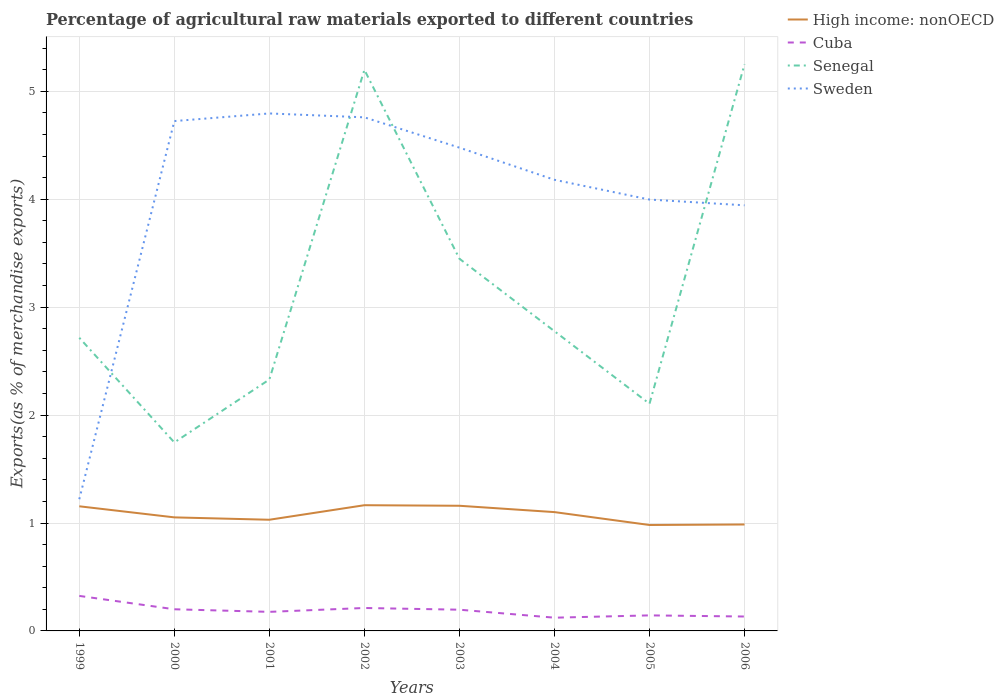How many different coloured lines are there?
Provide a succinct answer. 4. Does the line corresponding to Cuba intersect with the line corresponding to Senegal?
Your answer should be very brief. No. Is the number of lines equal to the number of legend labels?
Provide a succinct answer. Yes. Across all years, what is the maximum percentage of exports to different countries in Senegal?
Ensure brevity in your answer.  1.75. What is the total percentage of exports to different countries in Cuba in the graph?
Offer a terse response. 0.02. What is the difference between the highest and the second highest percentage of exports to different countries in Sweden?
Offer a terse response. 3.57. What is the difference between the highest and the lowest percentage of exports to different countries in Sweden?
Give a very brief answer. 5. Is the percentage of exports to different countries in Cuba strictly greater than the percentage of exports to different countries in High income: nonOECD over the years?
Ensure brevity in your answer.  Yes. How many lines are there?
Ensure brevity in your answer.  4. Does the graph contain any zero values?
Give a very brief answer. No. Where does the legend appear in the graph?
Ensure brevity in your answer.  Top right. How many legend labels are there?
Your answer should be compact. 4. How are the legend labels stacked?
Offer a terse response. Vertical. What is the title of the graph?
Your answer should be compact. Percentage of agricultural raw materials exported to different countries. Does "Nicaragua" appear as one of the legend labels in the graph?
Ensure brevity in your answer.  No. What is the label or title of the Y-axis?
Your answer should be very brief. Exports(as % of merchandise exports). What is the Exports(as % of merchandise exports) in High income: nonOECD in 1999?
Your answer should be compact. 1.15. What is the Exports(as % of merchandise exports) of Cuba in 1999?
Offer a very short reply. 0.32. What is the Exports(as % of merchandise exports) in Senegal in 1999?
Ensure brevity in your answer.  2.72. What is the Exports(as % of merchandise exports) in Sweden in 1999?
Provide a succinct answer. 1.22. What is the Exports(as % of merchandise exports) of High income: nonOECD in 2000?
Your answer should be compact. 1.05. What is the Exports(as % of merchandise exports) in Cuba in 2000?
Your answer should be very brief. 0.2. What is the Exports(as % of merchandise exports) of Senegal in 2000?
Provide a succinct answer. 1.75. What is the Exports(as % of merchandise exports) in Sweden in 2000?
Provide a succinct answer. 4.72. What is the Exports(as % of merchandise exports) in High income: nonOECD in 2001?
Keep it short and to the point. 1.03. What is the Exports(as % of merchandise exports) in Cuba in 2001?
Give a very brief answer. 0.18. What is the Exports(as % of merchandise exports) in Senegal in 2001?
Offer a terse response. 2.33. What is the Exports(as % of merchandise exports) in Sweden in 2001?
Provide a short and direct response. 4.8. What is the Exports(as % of merchandise exports) in High income: nonOECD in 2002?
Make the answer very short. 1.16. What is the Exports(as % of merchandise exports) of Cuba in 2002?
Make the answer very short. 0.21. What is the Exports(as % of merchandise exports) in Senegal in 2002?
Make the answer very short. 5.2. What is the Exports(as % of merchandise exports) in Sweden in 2002?
Make the answer very short. 4.76. What is the Exports(as % of merchandise exports) of High income: nonOECD in 2003?
Give a very brief answer. 1.16. What is the Exports(as % of merchandise exports) of Cuba in 2003?
Provide a short and direct response. 0.2. What is the Exports(as % of merchandise exports) of Senegal in 2003?
Provide a short and direct response. 3.45. What is the Exports(as % of merchandise exports) of Sweden in 2003?
Give a very brief answer. 4.48. What is the Exports(as % of merchandise exports) of High income: nonOECD in 2004?
Your answer should be very brief. 1.1. What is the Exports(as % of merchandise exports) of Cuba in 2004?
Your response must be concise. 0.12. What is the Exports(as % of merchandise exports) in Senegal in 2004?
Your answer should be very brief. 2.78. What is the Exports(as % of merchandise exports) of Sweden in 2004?
Offer a terse response. 4.18. What is the Exports(as % of merchandise exports) in High income: nonOECD in 2005?
Ensure brevity in your answer.  0.98. What is the Exports(as % of merchandise exports) in Cuba in 2005?
Your answer should be very brief. 0.14. What is the Exports(as % of merchandise exports) of Senegal in 2005?
Keep it short and to the point. 2.11. What is the Exports(as % of merchandise exports) of Sweden in 2005?
Ensure brevity in your answer.  4. What is the Exports(as % of merchandise exports) in High income: nonOECD in 2006?
Give a very brief answer. 0.99. What is the Exports(as % of merchandise exports) of Cuba in 2006?
Offer a terse response. 0.13. What is the Exports(as % of merchandise exports) in Senegal in 2006?
Offer a terse response. 5.25. What is the Exports(as % of merchandise exports) of Sweden in 2006?
Provide a succinct answer. 3.94. Across all years, what is the maximum Exports(as % of merchandise exports) of High income: nonOECD?
Keep it short and to the point. 1.16. Across all years, what is the maximum Exports(as % of merchandise exports) of Cuba?
Your response must be concise. 0.32. Across all years, what is the maximum Exports(as % of merchandise exports) in Senegal?
Ensure brevity in your answer.  5.25. Across all years, what is the maximum Exports(as % of merchandise exports) of Sweden?
Your answer should be compact. 4.8. Across all years, what is the minimum Exports(as % of merchandise exports) in High income: nonOECD?
Keep it short and to the point. 0.98. Across all years, what is the minimum Exports(as % of merchandise exports) in Cuba?
Provide a succinct answer. 0.12. Across all years, what is the minimum Exports(as % of merchandise exports) of Senegal?
Ensure brevity in your answer.  1.75. Across all years, what is the minimum Exports(as % of merchandise exports) of Sweden?
Offer a very short reply. 1.22. What is the total Exports(as % of merchandise exports) in High income: nonOECD in the graph?
Keep it short and to the point. 8.63. What is the total Exports(as % of merchandise exports) in Cuba in the graph?
Your response must be concise. 1.51. What is the total Exports(as % of merchandise exports) of Senegal in the graph?
Your response must be concise. 25.57. What is the total Exports(as % of merchandise exports) of Sweden in the graph?
Your answer should be very brief. 32.1. What is the difference between the Exports(as % of merchandise exports) of High income: nonOECD in 1999 and that in 2000?
Ensure brevity in your answer.  0.1. What is the difference between the Exports(as % of merchandise exports) in Cuba in 1999 and that in 2000?
Ensure brevity in your answer.  0.12. What is the difference between the Exports(as % of merchandise exports) of Senegal in 1999 and that in 2000?
Offer a terse response. 0.97. What is the difference between the Exports(as % of merchandise exports) of Sweden in 1999 and that in 2000?
Your answer should be compact. -3.5. What is the difference between the Exports(as % of merchandise exports) in High income: nonOECD in 1999 and that in 2001?
Offer a terse response. 0.12. What is the difference between the Exports(as % of merchandise exports) of Cuba in 1999 and that in 2001?
Keep it short and to the point. 0.15. What is the difference between the Exports(as % of merchandise exports) of Senegal in 1999 and that in 2001?
Your answer should be compact. 0.39. What is the difference between the Exports(as % of merchandise exports) of Sweden in 1999 and that in 2001?
Ensure brevity in your answer.  -3.57. What is the difference between the Exports(as % of merchandise exports) of High income: nonOECD in 1999 and that in 2002?
Offer a very short reply. -0.01. What is the difference between the Exports(as % of merchandise exports) in Cuba in 1999 and that in 2002?
Your answer should be very brief. 0.11. What is the difference between the Exports(as % of merchandise exports) of Senegal in 1999 and that in 2002?
Offer a very short reply. -2.48. What is the difference between the Exports(as % of merchandise exports) of Sweden in 1999 and that in 2002?
Keep it short and to the point. -3.54. What is the difference between the Exports(as % of merchandise exports) of High income: nonOECD in 1999 and that in 2003?
Make the answer very short. -0. What is the difference between the Exports(as % of merchandise exports) in Cuba in 1999 and that in 2003?
Offer a terse response. 0.13. What is the difference between the Exports(as % of merchandise exports) in Senegal in 1999 and that in 2003?
Give a very brief answer. -0.73. What is the difference between the Exports(as % of merchandise exports) in Sweden in 1999 and that in 2003?
Ensure brevity in your answer.  -3.26. What is the difference between the Exports(as % of merchandise exports) in High income: nonOECD in 1999 and that in 2004?
Your answer should be very brief. 0.05. What is the difference between the Exports(as % of merchandise exports) in Cuba in 1999 and that in 2004?
Your answer should be very brief. 0.2. What is the difference between the Exports(as % of merchandise exports) in Senegal in 1999 and that in 2004?
Make the answer very short. -0.06. What is the difference between the Exports(as % of merchandise exports) of Sweden in 1999 and that in 2004?
Offer a terse response. -2.96. What is the difference between the Exports(as % of merchandise exports) in High income: nonOECD in 1999 and that in 2005?
Keep it short and to the point. 0.17. What is the difference between the Exports(as % of merchandise exports) of Cuba in 1999 and that in 2005?
Make the answer very short. 0.18. What is the difference between the Exports(as % of merchandise exports) in Senegal in 1999 and that in 2005?
Offer a very short reply. 0.61. What is the difference between the Exports(as % of merchandise exports) in Sweden in 1999 and that in 2005?
Offer a terse response. -2.78. What is the difference between the Exports(as % of merchandise exports) of High income: nonOECD in 1999 and that in 2006?
Keep it short and to the point. 0.17. What is the difference between the Exports(as % of merchandise exports) in Cuba in 1999 and that in 2006?
Give a very brief answer. 0.19. What is the difference between the Exports(as % of merchandise exports) in Senegal in 1999 and that in 2006?
Offer a very short reply. -2.53. What is the difference between the Exports(as % of merchandise exports) of Sweden in 1999 and that in 2006?
Ensure brevity in your answer.  -2.72. What is the difference between the Exports(as % of merchandise exports) in High income: nonOECD in 2000 and that in 2001?
Your answer should be very brief. 0.02. What is the difference between the Exports(as % of merchandise exports) of Cuba in 2000 and that in 2001?
Provide a succinct answer. 0.02. What is the difference between the Exports(as % of merchandise exports) in Senegal in 2000 and that in 2001?
Your response must be concise. -0.58. What is the difference between the Exports(as % of merchandise exports) in Sweden in 2000 and that in 2001?
Ensure brevity in your answer.  -0.07. What is the difference between the Exports(as % of merchandise exports) of High income: nonOECD in 2000 and that in 2002?
Give a very brief answer. -0.11. What is the difference between the Exports(as % of merchandise exports) in Cuba in 2000 and that in 2002?
Provide a short and direct response. -0.01. What is the difference between the Exports(as % of merchandise exports) of Senegal in 2000 and that in 2002?
Your response must be concise. -3.45. What is the difference between the Exports(as % of merchandise exports) in Sweden in 2000 and that in 2002?
Your answer should be very brief. -0.03. What is the difference between the Exports(as % of merchandise exports) in High income: nonOECD in 2000 and that in 2003?
Provide a short and direct response. -0.11. What is the difference between the Exports(as % of merchandise exports) in Cuba in 2000 and that in 2003?
Ensure brevity in your answer.  0. What is the difference between the Exports(as % of merchandise exports) of Senegal in 2000 and that in 2003?
Your response must be concise. -1.7. What is the difference between the Exports(as % of merchandise exports) in Sweden in 2000 and that in 2003?
Your response must be concise. 0.25. What is the difference between the Exports(as % of merchandise exports) of High income: nonOECD in 2000 and that in 2004?
Provide a short and direct response. -0.05. What is the difference between the Exports(as % of merchandise exports) of Cuba in 2000 and that in 2004?
Make the answer very short. 0.08. What is the difference between the Exports(as % of merchandise exports) in Senegal in 2000 and that in 2004?
Make the answer very short. -1.03. What is the difference between the Exports(as % of merchandise exports) in Sweden in 2000 and that in 2004?
Ensure brevity in your answer.  0.54. What is the difference between the Exports(as % of merchandise exports) in High income: nonOECD in 2000 and that in 2005?
Provide a succinct answer. 0.07. What is the difference between the Exports(as % of merchandise exports) in Cuba in 2000 and that in 2005?
Ensure brevity in your answer.  0.06. What is the difference between the Exports(as % of merchandise exports) in Senegal in 2000 and that in 2005?
Your answer should be compact. -0.36. What is the difference between the Exports(as % of merchandise exports) of Sweden in 2000 and that in 2005?
Offer a very short reply. 0.73. What is the difference between the Exports(as % of merchandise exports) of High income: nonOECD in 2000 and that in 2006?
Offer a terse response. 0.07. What is the difference between the Exports(as % of merchandise exports) of Cuba in 2000 and that in 2006?
Provide a succinct answer. 0.07. What is the difference between the Exports(as % of merchandise exports) in Senegal in 2000 and that in 2006?
Make the answer very short. -3.5. What is the difference between the Exports(as % of merchandise exports) in Sweden in 2000 and that in 2006?
Your answer should be compact. 0.78. What is the difference between the Exports(as % of merchandise exports) of High income: nonOECD in 2001 and that in 2002?
Offer a very short reply. -0.13. What is the difference between the Exports(as % of merchandise exports) of Cuba in 2001 and that in 2002?
Keep it short and to the point. -0.04. What is the difference between the Exports(as % of merchandise exports) in Senegal in 2001 and that in 2002?
Offer a very short reply. -2.87. What is the difference between the Exports(as % of merchandise exports) of Sweden in 2001 and that in 2002?
Give a very brief answer. 0.04. What is the difference between the Exports(as % of merchandise exports) in High income: nonOECD in 2001 and that in 2003?
Provide a succinct answer. -0.13. What is the difference between the Exports(as % of merchandise exports) of Cuba in 2001 and that in 2003?
Offer a very short reply. -0.02. What is the difference between the Exports(as % of merchandise exports) of Senegal in 2001 and that in 2003?
Your answer should be compact. -1.12. What is the difference between the Exports(as % of merchandise exports) in Sweden in 2001 and that in 2003?
Keep it short and to the point. 0.32. What is the difference between the Exports(as % of merchandise exports) in High income: nonOECD in 2001 and that in 2004?
Your answer should be compact. -0.07. What is the difference between the Exports(as % of merchandise exports) of Cuba in 2001 and that in 2004?
Offer a terse response. 0.05. What is the difference between the Exports(as % of merchandise exports) of Senegal in 2001 and that in 2004?
Provide a short and direct response. -0.45. What is the difference between the Exports(as % of merchandise exports) in Sweden in 2001 and that in 2004?
Offer a very short reply. 0.61. What is the difference between the Exports(as % of merchandise exports) in High income: nonOECD in 2001 and that in 2005?
Provide a succinct answer. 0.05. What is the difference between the Exports(as % of merchandise exports) in Cuba in 2001 and that in 2005?
Make the answer very short. 0.03. What is the difference between the Exports(as % of merchandise exports) in Senegal in 2001 and that in 2005?
Offer a very short reply. 0.22. What is the difference between the Exports(as % of merchandise exports) of Sweden in 2001 and that in 2005?
Keep it short and to the point. 0.8. What is the difference between the Exports(as % of merchandise exports) of High income: nonOECD in 2001 and that in 2006?
Your answer should be compact. 0.04. What is the difference between the Exports(as % of merchandise exports) in Cuba in 2001 and that in 2006?
Your answer should be compact. 0.04. What is the difference between the Exports(as % of merchandise exports) of Senegal in 2001 and that in 2006?
Offer a terse response. -2.92. What is the difference between the Exports(as % of merchandise exports) of Sweden in 2001 and that in 2006?
Provide a short and direct response. 0.85. What is the difference between the Exports(as % of merchandise exports) in High income: nonOECD in 2002 and that in 2003?
Your answer should be compact. 0.01. What is the difference between the Exports(as % of merchandise exports) of Cuba in 2002 and that in 2003?
Offer a terse response. 0.02. What is the difference between the Exports(as % of merchandise exports) in Senegal in 2002 and that in 2003?
Give a very brief answer. 1.75. What is the difference between the Exports(as % of merchandise exports) of Sweden in 2002 and that in 2003?
Provide a succinct answer. 0.28. What is the difference between the Exports(as % of merchandise exports) of High income: nonOECD in 2002 and that in 2004?
Provide a succinct answer. 0.06. What is the difference between the Exports(as % of merchandise exports) in Cuba in 2002 and that in 2004?
Keep it short and to the point. 0.09. What is the difference between the Exports(as % of merchandise exports) in Senegal in 2002 and that in 2004?
Ensure brevity in your answer.  2.42. What is the difference between the Exports(as % of merchandise exports) in Sweden in 2002 and that in 2004?
Offer a very short reply. 0.58. What is the difference between the Exports(as % of merchandise exports) of High income: nonOECD in 2002 and that in 2005?
Give a very brief answer. 0.18. What is the difference between the Exports(as % of merchandise exports) of Cuba in 2002 and that in 2005?
Provide a short and direct response. 0.07. What is the difference between the Exports(as % of merchandise exports) in Senegal in 2002 and that in 2005?
Provide a succinct answer. 3.09. What is the difference between the Exports(as % of merchandise exports) of Sweden in 2002 and that in 2005?
Your response must be concise. 0.76. What is the difference between the Exports(as % of merchandise exports) of High income: nonOECD in 2002 and that in 2006?
Provide a succinct answer. 0.18. What is the difference between the Exports(as % of merchandise exports) in Cuba in 2002 and that in 2006?
Give a very brief answer. 0.08. What is the difference between the Exports(as % of merchandise exports) of Senegal in 2002 and that in 2006?
Provide a succinct answer. -0.05. What is the difference between the Exports(as % of merchandise exports) of Sweden in 2002 and that in 2006?
Your answer should be very brief. 0.82. What is the difference between the Exports(as % of merchandise exports) of High income: nonOECD in 2003 and that in 2004?
Keep it short and to the point. 0.06. What is the difference between the Exports(as % of merchandise exports) of Cuba in 2003 and that in 2004?
Your response must be concise. 0.07. What is the difference between the Exports(as % of merchandise exports) in Senegal in 2003 and that in 2004?
Provide a succinct answer. 0.67. What is the difference between the Exports(as % of merchandise exports) in Sweden in 2003 and that in 2004?
Your answer should be very brief. 0.3. What is the difference between the Exports(as % of merchandise exports) in High income: nonOECD in 2003 and that in 2005?
Your answer should be compact. 0.18. What is the difference between the Exports(as % of merchandise exports) in Cuba in 2003 and that in 2005?
Make the answer very short. 0.05. What is the difference between the Exports(as % of merchandise exports) in Senegal in 2003 and that in 2005?
Your answer should be very brief. 1.34. What is the difference between the Exports(as % of merchandise exports) in Sweden in 2003 and that in 2005?
Your answer should be very brief. 0.48. What is the difference between the Exports(as % of merchandise exports) in High income: nonOECD in 2003 and that in 2006?
Your answer should be compact. 0.17. What is the difference between the Exports(as % of merchandise exports) in Cuba in 2003 and that in 2006?
Make the answer very short. 0.06. What is the difference between the Exports(as % of merchandise exports) in Senegal in 2003 and that in 2006?
Your response must be concise. -1.8. What is the difference between the Exports(as % of merchandise exports) in Sweden in 2003 and that in 2006?
Your answer should be compact. 0.53. What is the difference between the Exports(as % of merchandise exports) in High income: nonOECD in 2004 and that in 2005?
Provide a short and direct response. 0.12. What is the difference between the Exports(as % of merchandise exports) in Cuba in 2004 and that in 2005?
Your answer should be very brief. -0.02. What is the difference between the Exports(as % of merchandise exports) of Senegal in 2004 and that in 2005?
Give a very brief answer. 0.67. What is the difference between the Exports(as % of merchandise exports) of Sweden in 2004 and that in 2005?
Ensure brevity in your answer.  0.18. What is the difference between the Exports(as % of merchandise exports) of High income: nonOECD in 2004 and that in 2006?
Offer a very short reply. 0.11. What is the difference between the Exports(as % of merchandise exports) of Cuba in 2004 and that in 2006?
Offer a very short reply. -0.01. What is the difference between the Exports(as % of merchandise exports) of Senegal in 2004 and that in 2006?
Provide a succinct answer. -2.47. What is the difference between the Exports(as % of merchandise exports) of Sweden in 2004 and that in 2006?
Your answer should be very brief. 0.24. What is the difference between the Exports(as % of merchandise exports) in High income: nonOECD in 2005 and that in 2006?
Ensure brevity in your answer.  -0. What is the difference between the Exports(as % of merchandise exports) in Cuba in 2005 and that in 2006?
Give a very brief answer. 0.01. What is the difference between the Exports(as % of merchandise exports) in Senegal in 2005 and that in 2006?
Offer a very short reply. -3.15. What is the difference between the Exports(as % of merchandise exports) in Sweden in 2005 and that in 2006?
Offer a terse response. 0.05. What is the difference between the Exports(as % of merchandise exports) of High income: nonOECD in 1999 and the Exports(as % of merchandise exports) of Cuba in 2000?
Your answer should be very brief. 0.95. What is the difference between the Exports(as % of merchandise exports) in High income: nonOECD in 1999 and the Exports(as % of merchandise exports) in Senegal in 2000?
Offer a very short reply. -0.59. What is the difference between the Exports(as % of merchandise exports) in High income: nonOECD in 1999 and the Exports(as % of merchandise exports) in Sweden in 2000?
Your answer should be very brief. -3.57. What is the difference between the Exports(as % of merchandise exports) of Cuba in 1999 and the Exports(as % of merchandise exports) of Senegal in 2000?
Your response must be concise. -1.42. What is the difference between the Exports(as % of merchandise exports) of Cuba in 1999 and the Exports(as % of merchandise exports) of Sweden in 2000?
Offer a very short reply. -4.4. What is the difference between the Exports(as % of merchandise exports) of Senegal in 1999 and the Exports(as % of merchandise exports) of Sweden in 2000?
Ensure brevity in your answer.  -2.01. What is the difference between the Exports(as % of merchandise exports) in High income: nonOECD in 1999 and the Exports(as % of merchandise exports) in Cuba in 2001?
Provide a short and direct response. 0.98. What is the difference between the Exports(as % of merchandise exports) of High income: nonOECD in 1999 and the Exports(as % of merchandise exports) of Senegal in 2001?
Ensure brevity in your answer.  -1.17. What is the difference between the Exports(as % of merchandise exports) in High income: nonOECD in 1999 and the Exports(as % of merchandise exports) in Sweden in 2001?
Offer a very short reply. -3.64. What is the difference between the Exports(as % of merchandise exports) in Cuba in 1999 and the Exports(as % of merchandise exports) in Senegal in 2001?
Provide a succinct answer. -2.01. What is the difference between the Exports(as % of merchandise exports) in Cuba in 1999 and the Exports(as % of merchandise exports) in Sweden in 2001?
Offer a terse response. -4.47. What is the difference between the Exports(as % of merchandise exports) of Senegal in 1999 and the Exports(as % of merchandise exports) of Sweden in 2001?
Provide a short and direct response. -2.08. What is the difference between the Exports(as % of merchandise exports) of High income: nonOECD in 1999 and the Exports(as % of merchandise exports) of Cuba in 2002?
Ensure brevity in your answer.  0.94. What is the difference between the Exports(as % of merchandise exports) in High income: nonOECD in 1999 and the Exports(as % of merchandise exports) in Senegal in 2002?
Provide a short and direct response. -4.04. What is the difference between the Exports(as % of merchandise exports) of High income: nonOECD in 1999 and the Exports(as % of merchandise exports) of Sweden in 2002?
Your answer should be very brief. -3.6. What is the difference between the Exports(as % of merchandise exports) of Cuba in 1999 and the Exports(as % of merchandise exports) of Senegal in 2002?
Ensure brevity in your answer.  -4.88. What is the difference between the Exports(as % of merchandise exports) of Cuba in 1999 and the Exports(as % of merchandise exports) of Sweden in 2002?
Provide a short and direct response. -4.43. What is the difference between the Exports(as % of merchandise exports) in Senegal in 1999 and the Exports(as % of merchandise exports) in Sweden in 2002?
Make the answer very short. -2.04. What is the difference between the Exports(as % of merchandise exports) in High income: nonOECD in 1999 and the Exports(as % of merchandise exports) in Cuba in 2003?
Keep it short and to the point. 0.96. What is the difference between the Exports(as % of merchandise exports) of High income: nonOECD in 1999 and the Exports(as % of merchandise exports) of Senegal in 2003?
Make the answer very short. -2.29. What is the difference between the Exports(as % of merchandise exports) in High income: nonOECD in 1999 and the Exports(as % of merchandise exports) in Sweden in 2003?
Give a very brief answer. -3.32. What is the difference between the Exports(as % of merchandise exports) of Cuba in 1999 and the Exports(as % of merchandise exports) of Senegal in 2003?
Offer a very short reply. -3.12. What is the difference between the Exports(as % of merchandise exports) of Cuba in 1999 and the Exports(as % of merchandise exports) of Sweden in 2003?
Your response must be concise. -4.15. What is the difference between the Exports(as % of merchandise exports) of Senegal in 1999 and the Exports(as % of merchandise exports) of Sweden in 2003?
Offer a very short reply. -1.76. What is the difference between the Exports(as % of merchandise exports) in High income: nonOECD in 1999 and the Exports(as % of merchandise exports) in Cuba in 2004?
Your response must be concise. 1.03. What is the difference between the Exports(as % of merchandise exports) of High income: nonOECD in 1999 and the Exports(as % of merchandise exports) of Senegal in 2004?
Your answer should be compact. -1.62. What is the difference between the Exports(as % of merchandise exports) of High income: nonOECD in 1999 and the Exports(as % of merchandise exports) of Sweden in 2004?
Keep it short and to the point. -3.03. What is the difference between the Exports(as % of merchandise exports) of Cuba in 1999 and the Exports(as % of merchandise exports) of Senegal in 2004?
Provide a short and direct response. -2.45. What is the difference between the Exports(as % of merchandise exports) in Cuba in 1999 and the Exports(as % of merchandise exports) in Sweden in 2004?
Provide a short and direct response. -3.86. What is the difference between the Exports(as % of merchandise exports) of Senegal in 1999 and the Exports(as % of merchandise exports) of Sweden in 2004?
Your answer should be compact. -1.46. What is the difference between the Exports(as % of merchandise exports) of High income: nonOECD in 1999 and the Exports(as % of merchandise exports) of Cuba in 2005?
Ensure brevity in your answer.  1.01. What is the difference between the Exports(as % of merchandise exports) of High income: nonOECD in 1999 and the Exports(as % of merchandise exports) of Senegal in 2005?
Your response must be concise. -0.95. What is the difference between the Exports(as % of merchandise exports) of High income: nonOECD in 1999 and the Exports(as % of merchandise exports) of Sweden in 2005?
Give a very brief answer. -2.84. What is the difference between the Exports(as % of merchandise exports) in Cuba in 1999 and the Exports(as % of merchandise exports) in Senegal in 2005?
Ensure brevity in your answer.  -1.78. What is the difference between the Exports(as % of merchandise exports) in Cuba in 1999 and the Exports(as % of merchandise exports) in Sweden in 2005?
Your response must be concise. -3.67. What is the difference between the Exports(as % of merchandise exports) of Senegal in 1999 and the Exports(as % of merchandise exports) of Sweden in 2005?
Your answer should be compact. -1.28. What is the difference between the Exports(as % of merchandise exports) in High income: nonOECD in 1999 and the Exports(as % of merchandise exports) in Cuba in 2006?
Your answer should be compact. 1.02. What is the difference between the Exports(as % of merchandise exports) of High income: nonOECD in 1999 and the Exports(as % of merchandise exports) of Senegal in 2006?
Offer a terse response. -4.1. What is the difference between the Exports(as % of merchandise exports) in High income: nonOECD in 1999 and the Exports(as % of merchandise exports) in Sweden in 2006?
Offer a terse response. -2.79. What is the difference between the Exports(as % of merchandise exports) of Cuba in 1999 and the Exports(as % of merchandise exports) of Senegal in 2006?
Your answer should be very brief. -4.93. What is the difference between the Exports(as % of merchandise exports) of Cuba in 1999 and the Exports(as % of merchandise exports) of Sweden in 2006?
Offer a terse response. -3.62. What is the difference between the Exports(as % of merchandise exports) of Senegal in 1999 and the Exports(as % of merchandise exports) of Sweden in 2006?
Provide a succinct answer. -1.23. What is the difference between the Exports(as % of merchandise exports) of High income: nonOECD in 2000 and the Exports(as % of merchandise exports) of Cuba in 2001?
Your answer should be compact. 0.88. What is the difference between the Exports(as % of merchandise exports) in High income: nonOECD in 2000 and the Exports(as % of merchandise exports) in Senegal in 2001?
Your answer should be compact. -1.28. What is the difference between the Exports(as % of merchandise exports) of High income: nonOECD in 2000 and the Exports(as % of merchandise exports) of Sweden in 2001?
Offer a very short reply. -3.74. What is the difference between the Exports(as % of merchandise exports) in Cuba in 2000 and the Exports(as % of merchandise exports) in Senegal in 2001?
Your response must be concise. -2.13. What is the difference between the Exports(as % of merchandise exports) in Cuba in 2000 and the Exports(as % of merchandise exports) in Sweden in 2001?
Make the answer very short. -4.59. What is the difference between the Exports(as % of merchandise exports) of Senegal in 2000 and the Exports(as % of merchandise exports) of Sweden in 2001?
Provide a succinct answer. -3.05. What is the difference between the Exports(as % of merchandise exports) in High income: nonOECD in 2000 and the Exports(as % of merchandise exports) in Cuba in 2002?
Provide a short and direct response. 0.84. What is the difference between the Exports(as % of merchandise exports) of High income: nonOECD in 2000 and the Exports(as % of merchandise exports) of Senegal in 2002?
Your answer should be very brief. -4.15. What is the difference between the Exports(as % of merchandise exports) of High income: nonOECD in 2000 and the Exports(as % of merchandise exports) of Sweden in 2002?
Your answer should be very brief. -3.71. What is the difference between the Exports(as % of merchandise exports) in Cuba in 2000 and the Exports(as % of merchandise exports) in Senegal in 2002?
Your response must be concise. -5. What is the difference between the Exports(as % of merchandise exports) in Cuba in 2000 and the Exports(as % of merchandise exports) in Sweden in 2002?
Your response must be concise. -4.56. What is the difference between the Exports(as % of merchandise exports) in Senegal in 2000 and the Exports(as % of merchandise exports) in Sweden in 2002?
Offer a very short reply. -3.01. What is the difference between the Exports(as % of merchandise exports) in High income: nonOECD in 2000 and the Exports(as % of merchandise exports) in Cuba in 2003?
Provide a succinct answer. 0.86. What is the difference between the Exports(as % of merchandise exports) of High income: nonOECD in 2000 and the Exports(as % of merchandise exports) of Senegal in 2003?
Offer a very short reply. -2.4. What is the difference between the Exports(as % of merchandise exports) of High income: nonOECD in 2000 and the Exports(as % of merchandise exports) of Sweden in 2003?
Give a very brief answer. -3.43. What is the difference between the Exports(as % of merchandise exports) of Cuba in 2000 and the Exports(as % of merchandise exports) of Senegal in 2003?
Your response must be concise. -3.25. What is the difference between the Exports(as % of merchandise exports) in Cuba in 2000 and the Exports(as % of merchandise exports) in Sweden in 2003?
Provide a short and direct response. -4.28. What is the difference between the Exports(as % of merchandise exports) of Senegal in 2000 and the Exports(as % of merchandise exports) of Sweden in 2003?
Your answer should be compact. -2.73. What is the difference between the Exports(as % of merchandise exports) of High income: nonOECD in 2000 and the Exports(as % of merchandise exports) of Cuba in 2004?
Offer a very short reply. 0.93. What is the difference between the Exports(as % of merchandise exports) of High income: nonOECD in 2000 and the Exports(as % of merchandise exports) of Senegal in 2004?
Make the answer very short. -1.73. What is the difference between the Exports(as % of merchandise exports) of High income: nonOECD in 2000 and the Exports(as % of merchandise exports) of Sweden in 2004?
Your answer should be compact. -3.13. What is the difference between the Exports(as % of merchandise exports) in Cuba in 2000 and the Exports(as % of merchandise exports) in Senegal in 2004?
Your answer should be very brief. -2.58. What is the difference between the Exports(as % of merchandise exports) of Cuba in 2000 and the Exports(as % of merchandise exports) of Sweden in 2004?
Your answer should be very brief. -3.98. What is the difference between the Exports(as % of merchandise exports) in Senegal in 2000 and the Exports(as % of merchandise exports) in Sweden in 2004?
Offer a terse response. -2.43. What is the difference between the Exports(as % of merchandise exports) in High income: nonOECD in 2000 and the Exports(as % of merchandise exports) in Cuba in 2005?
Your response must be concise. 0.91. What is the difference between the Exports(as % of merchandise exports) of High income: nonOECD in 2000 and the Exports(as % of merchandise exports) of Senegal in 2005?
Your answer should be very brief. -1.05. What is the difference between the Exports(as % of merchandise exports) in High income: nonOECD in 2000 and the Exports(as % of merchandise exports) in Sweden in 2005?
Give a very brief answer. -2.94. What is the difference between the Exports(as % of merchandise exports) in Cuba in 2000 and the Exports(as % of merchandise exports) in Senegal in 2005?
Provide a short and direct response. -1.9. What is the difference between the Exports(as % of merchandise exports) of Cuba in 2000 and the Exports(as % of merchandise exports) of Sweden in 2005?
Provide a succinct answer. -3.8. What is the difference between the Exports(as % of merchandise exports) of Senegal in 2000 and the Exports(as % of merchandise exports) of Sweden in 2005?
Provide a short and direct response. -2.25. What is the difference between the Exports(as % of merchandise exports) of High income: nonOECD in 2000 and the Exports(as % of merchandise exports) of Cuba in 2006?
Your response must be concise. 0.92. What is the difference between the Exports(as % of merchandise exports) in High income: nonOECD in 2000 and the Exports(as % of merchandise exports) in Senegal in 2006?
Provide a short and direct response. -4.2. What is the difference between the Exports(as % of merchandise exports) of High income: nonOECD in 2000 and the Exports(as % of merchandise exports) of Sweden in 2006?
Offer a terse response. -2.89. What is the difference between the Exports(as % of merchandise exports) in Cuba in 2000 and the Exports(as % of merchandise exports) in Senegal in 2006?
Offer a very short reply. -5.05. What is the difference between the Exports(as % of merchandise exports) of Cuba in 2000 and the Exports(as % of merchandise exports) of Sweden in 2006?
Give a very brief answer. -3.74. What is the difference between the Exports(as % of merchandise exports) in Senegal in 2000 and the Exports(as % of merchandise exports) in Sweden in 2006?
Keep it short and to the point. -2.2. What is the difference between the Exports(as % of merchandise exports) in High income: nonOECD in 2001 and the Exports(as % of merchandise exports) in Cuba in 2002?
Offer a terse response. 0.82. What is the difference between the Exports(as % of merchandise exports) of High income: nonOECD in 2001 and the Exports(as % of merchandise exports) of Senegal in 2002?
Provide a short and direct response. -4.17. What is the difference between the Exports(as % of merchandise exports) of High income: nonOECD in 2001 and the Exports(as % of merchandise exports) of Sweden in 2002?
Give a very brief answer. -3.73. What is the difference between the Exports(as % of merchandise exports) in Cuba in 2001 and the Exports(as % of merchandise exports) in Senegal in 2002?
Your response must be concise. -5.02. What is the difference between the Exports(as % of merchandise exports) of Cuba in 2001 and the Exports(as % of merchandise exports) of Sweden in 2002?
Provide a succinct answer. -4.58. What is the difference between the Exports(as % of merchandise exports) of Senegal in 2001 and the Exports(as % of merchandise exports) of Sweden in 2002?
Give a very brief answer. -2.43. What is the difference between the Exports(as % of merchandise exports) of High income: nonOECD in 2001 and the Exports(as % of merchandise exports) of Cuba in 2003?
Offer a very short reply. 0.83. What is the difference between the Exports(as % of merchandise exports) in High income: nonOECD in 2001 and the Exports(as % of merchandise exports) in Senegal in 2003?
Ensure brevity in your answer.  -2.42. What is the difference between the Exports(as % of merchandise exports) of High income: nonOECD in 2001 and the Exports(as % of merchandise exports) of Sweden in 2003?
Make the answer very short. -3.45. What is the difference between the Exports(as % of merchandise exports) of Cuba in 2001 and the Exports(as % of merchandise exports) of Senegal in 2003?
Ensure brevity in your answer.  -3.27. What is the difference between the Exports(as % of merchandise exports) in Cuba in 2001 and the Exports(as % of merchandise exports) in Sweden in 2003?
Your answer should be very brief. -4.3. What is the difference between the Exports(as % of merchandise exports) of Senegal in 2001 and the Exports(as % of merchandise exports) of Sweden in 2003?
Provide a short and direct response. -2.15. What is the difference between the Exports(as % of merchandise exports) in High income: nonOECD in 2001 and the Exports(as % of merchandise exports) in Cuba in 2004?
Offer a terse response. 0.91. What is the difference between the Exports(as % of merchandise exports) in High income: nonOECD in 2001 and the Exports(as % of merchandise exports) in Senegal in 2004?
Provide a succinct answer. -1.75. What is the difference between the Exports(as % of merchandise exports) in High income: nonOECD in 2001 and the Exports(as % of merchandise exports) in Sweden in 2004?
Offer a terse response. -3.15. What is the difference between the Exports(as % of merchandise exports) in Cuba in 2001 and the Exports(as % of merchandise exports) in Senegal in 2004?
Your answer should be very brief. -2.6. What is the difference between the Exports(as % of merchandise exports) in Cuba in 2001 and the Exports(as % of merchandise exports) in Sweden in 2004?
Your response must be concise. -4. What is the difference between the Exports(as % of merchandise exports) in Senegal in 2001 and the Exports(as % of merchandise exports) in Sweden in 2004?
Offer a terse response. -1.85. What is the difference between the Exports(as % of merchandise exports) in High income: nonOECD in 2001 and the Exports(as % of merchandise exports) in Cuba in 2005?
Make the answer very short. 0.89. What is the difference between the Exports(as % of merchandise exports) of High income: nonOECD in 2001 and the Exports(as % of merchandise exports) of Senegal in 2005?
Your response must be concise. -1.07. What is the difference between the Exports(as % of merchandise exports) in High income: nonOECD in 2001 and the Exports(as % of merchandise exports) in Sweden in 2005?
Keep it short and to the point. -2.97. What is the difference between the Exports(as % of merchandise exports) of Cuba in 2001 and the Exports(as % of merchandise exports) of Senegal in 2005?
Offer a very short reply. -1.93. What is the difference between the Exports(as % of merchandise exports) of Cuba in 2001 and the Exports(as % of merchandise exports) of Sweden in 2005?
Your answer should be compact. -3.82. What is the difference between the Exports(as % of merchandise exports) in Senegal in 2001 and the Exports(as % of merchandise exports) in Sweden in 2005?
Make the answer very short. -1.67. What is the difference between the Exports(as % of merchandise exports) of High income: nonOECD in 2001 and the Exports(as % of merchandise exports) of Cuba in 2006?
Provide a succinct answer. 0.9. What is the difference between the Exports(as % of merchandise exports) in High income: nonOECD in 2001 and the Exports(as % of merchandise exports) in Senegal in 2006?
Your response must be concise. -4.22. What is the difference between the Exports(as % of merchandise exports) of High income: nonOECD in 2001 and the Exports(as % of merchandise exports) of Sweden in 2006?
Offer a very short reply. -2.91. What is the difference between the Exports(as % of merchandise exports) of Cuba in 2001 and the Exports(as % of merchandise exports) of Senegal in 2006?
Offer a very short reply. -5.07. What is the difference between the Exports(as % of merchandise exports) in Cuba in 2001 and the Exports(as % of merchandise exports) in Sweden in 2006?
Your answer should be very brief. -3.77. What is the difference between the Exports(as % of merchandise exports) of Senegal in 2001 and the Exports(as % of merchandise exports) of Sweden in 2006?
Ensure brevity in your answer.  -1.61. What is the difference between the Exports(as % of merchandise exports) in High income: nonOECD in 2002 and the Exports(as % of merchandise exports) in Cuba in 2003?
Your answer should be very brief. 0.97. What is the difference between the Exports(as % of merchandise exports) of High income: nonOECD in 2002 and the Exports(as % of merchandise exports) of Senegal in 2003?
Provide a succinct answer. -2.28. What is the difference between the Exports(as % of merchandise exports) of High income: nonOECD in 2002 and the Exports(as % of merchandise exports) of Sweden in 2003?
Your response must be concise. -3.31. What is the difference between the Exports(as % of merchandise exports) in Cuba in 2002 and the Exports(as % of merchandise exports) in Senegal in 2003?
Provide a succinct answer. -3.24. What is the difference between the Exports(as % of merchandise exports) in Cuba in 2002 and the Exports(as % of merchandise exports) in Sweden in 2003?
Your response must be concise. -4.27. What is the difference between the Exports(as % of merchandise exports) in Senegal in 2002 and the Exports(as % of merchandise exports) in Sweden in 2003?
Offer a very short reply. 0.72. What is the difference between the Exports(as % of merchandise exports) in High income: nonOECD in 2002 and the Exports(as % of merchandise exports) in Cuba in 2004?
Your response must be concise. 1.04. What is the difference between the Exports(as % of merchandise exports) of High income: nonOECD in 2002 and the Exports(as % of merchandise exports) of Senegal in 2004?
Provide a short and direct response. -1.61. What is the difference between the Exports(as % of merchandise exports) of High income: nonOECD in 2002 and the Exports(as % of merchandise exports) of Sweden in 2004?
Keep it short and to the point. -3.02. What is the difference between the Exports(as % of merchandise exports) of Cuba in 2002 and the Exports(as % of merchandise exports) of Senegal in 2004?
Your answer should be very brief. -2.56. What is the difference between the Exports(as % of merchandise exports) of Cuba in 2002 and the Exports(as % of merchandise exports) of Sweden in 2004?
Keep it short and to the point. -3.97. What is the difference between the Exports(as % of merchandise exports) of Senegal in 2002 and the Exports(as % of merchandise exports) of Sweden in 2004?
Provide a short and direct response. 1.02. What is the difference between the Exports(as % of merchandise exports) of High income: nonOECD in 2002 and the Exports(as % of merchandise exports) of Cuba in 2005?
Provide a succinct answer. 1.02. What is the difference between the Exports(as % of merchandise exports) in High income: nonOECD in 2002 and the Exports(as % of merchandise exports) in Senegal in 2005?
Provide a succinct answer. -0.94. What is the difference between the Exports(as % of merchandise exports) of High income: nonOECD in 2002 and the Exports(as % of merchandise exports) of Sweden in 2005?
Provide a short and direct response. -2.83. What is the difference between the Exports(as % of merchandise exports) of Cuba in 2002 and the Exports(as % of merchandise exports) of Senegal in 2005?
Your answer should be very brief. -1.89. What is the difference between the Exports(as % of merchandise exports) of Cuba in 2002 and the Exports(as % of merchandise exports) of Sweden in 2005?
Offer a terse response. -3.78. What is the difference between the Exports(as % of merchandise exports) of Senegal in 2002 and the Exports(as % of merchandise exports) of Sweden in 2005?
Your response must be concise. 1.2. What is the difference between the Exports(as % of merchandise exports) in High income: nonOECD in 2002 and the Exports(as % of merchandise exports) in Cuba in 2006?
Provide a succinct answer. 1.03. What is the difference between the Exports(as % of merchandise exports) in High income: nonOECD in 2002 and the Exports(as % of merchandise exports) in Senegal in 2006?
Keep it short and to the point. -4.09. What is the difference between the Exports(as % of merchandise exports) of High income: nonOECD in 2002 and the Exports(as % of merchandise exports) of Sweden in 2006?
Ensure brevity in your answer.  -2.78. What is the difference between the Exports(as % of merchandise exports) of Cuba in 2002 and the Exports(as % of merchandise exports) of Senegal in 2006?
Offer a terse response. -5.04. What is the difference between the Exports(as % of merchandise exports) of Cuba in 2002 and the Exports(as % of merchandise exports) of Sweden in 2006?
Offer a terse response. -3.73. What is the difference between the Exports(as % of merchandise exports) of Senegal in 2002 and the Exports(as % of merchandise exports) of Sweden in 2006?
Provide a short and direct response. 1.26. What is the difference between the Exports(as % of merchandise exports) of High income: nonOECD in 2003 and the Exports(as % of merchandise exports) of Cuba in 2004?
Keep it short and to the point. 1.04. What is the difference between the Exports(as % of merchandise exports) of High income: nonOECD in 2003 and the Exports(as % of merchandise exports) of Senegal in 2004?
Your answer should be compact. -1.62. What is the difference between the Exports(as % of merchandise exports) of High income: nonOECD in 2003 and the Exports(as % of merchandise exports) of Sweden in 2004?
Keep it short and to the point. -3.02. What is the difference between the Exports(as % of merchandise exports) of Cuba in 2003 and the Exports(as % of merchandise exports) of Senegal in 2004?
Your answer should be very brief. -2.58. What is the difference between the Exports(as % of merchandise exports) in Cuba in 2003 and the Exports(as % of merchandise exports) in Sweden in 2004?
Offer a very short reply. -3.98. What is the difference between the Exports(as % of merchandise exports) in Senegal in 2003 and the Exports(as % of merchandise exports) in Sweden in 2004?
Keep it short and to the point. -0.73. What is the difference between the Exports(as % of merchandise exports) in High income: nonOECD in 2003 and the Exports(as % of merchandise exports) in Cuba in 2005?
Make the answer very short. 1.02. What is the difference between the Exports(as % of merchandise exports) in High income: nonOECD in 2003 and the Exports(as % of merchandise exports) in Senegal in 2005?
Provide a succinct answer. -0.95. What is the difference between the Exports(as % of merchandise exports) of High income: nonOECD in 2003 and the Exports(as % of merchandise exports) of Sweden in 2005?
Ensure brevity in your answer.  -2.84. What is the difference between the Exports(as % of merchandise exports) in Cuba in 2003 and the Exports(as % of merchandise exports) in Senegal in 2005?
Provide a short and direct response. -1.91. What is the difference between the Exports(as % of merchandise exports) in Cuba in 2003 and the Exports(as % of merchandise exports) in Sweden in 2005?
Offer a very short reply. -3.8. What is the difference between the Exports(as % of merchandise exports) of Senegal in 2003 and the Exports(as % of merchandise exports) of Sweden in 2005?
Offer a very short reply. -0.55. What is the difference between the Exports(as % of merchandise exports) of High income: nonOECD in 2003 and the Exports(as % of merchandise exports) of Cuba in 2006?
Provide a succinct answer. 1.03. What is the difference between the Exports(as % of merchandise exports) of High income: nonOECD in 2003 and the Exports(as % of merchandise exports) of Senegal in 2006?
Your answer should be compact. -4.09. What is the difference between the Exports(as % of merchandise exports) of High income: nonOECD in 2003 and the Exports(as % of merchandise exports) of Sweden in 2006?
Make the answer very short. -2.78. What is the difference between the Exports(as % of merchandise exports) in Cuba in 2003 and the Exports(as % of merchandise exports) in Senegal in 2006?
Your answer should be very brief. -5.05. What is the difference between the Exports(as % of merchandise exports) of Cuba in 2003 and the Exports(as % of merchandise exports) of Sweden in 2006?
Provide a succinct answer. -3.75. What is the difference between the Exports(as % of merchandise exports) of Senegal in 2003 and the Exports(as % of merchandise exports) of Sweden in 2006?
Provide a succinct answer. -0.5. What is the difference between the Exports(as % of merchandise exports) in High income: nonOECD in 2004 and the Exports(as % of merchandise exports) in Senegal in 2005?
Your response must be concise. -1. What is the difference between the Exports(as % of merchandise exports) of High income: nonOECD in 2004 and the Exports(as % of merchandise exports) of Sweden in 2005?
Make the answer very short. -2.9. What is the difference between the Exports(as % of merchandise exports) in Cuba in 2004 and the Exports(as % of merchandise exports) in Senegal in 2005?
Make the answer very short. -1.98. What is the difference between the Exports(as % of merchandise exports) of Cuba in 2004 and the Exports(as % of merchandise exports) of Sweden in 2005?
Provide a succinct answer. -3.87. What is the difference between the Exports(as % of merchandise exports) in Senegal in 2004 and the Exports(as % of merchandise exports) in Sweden in 2005?
Provide a succinct answer. -1.22. What is the difference between the Exports(as % of merchandise exports) in High income: nonOECD in 2004 and the Exports(as % of merchandise exports) in Cuba in 2006?
Your answer should be very brief. 0.97. What is the difference between the Exports(as % of merchandise exports) in High income: nonOECD in 2004 and the Exports(as % of merchandise exports) in Senegal in 2006?
Give a very brief answer. -4.15. What is the difference between the Exports(as % of merchandise exports) of High income: nonOECD in 2004 and the Exports(as % of merchandise exports) of Sweden in 2006?
Offer a terse response. -2.84. What is the difference between the Exports(as % of merchandise exports) of Cuba in 2004 and the Exports(as % of merchandise exports) of Senegal in 2006?
Make the answer very short. -5.13. What is the difference between the Exports(as % of merchandise exports) of Cuba in 2004 and the Exports(as % of merchandise exports) of Sweden in 2006?
Provide a succinct answer. -3.82. What is the difference between the Exports(as % of merchandise exports) of Senegal in 2004 and the Exports(as % of merchandise exports) of Sweden in 2006?
Your answer should be very brief. -1.17. What is the difference between the Exports(as % of merchandise exports) in High income: nonOECD in 2005 and the Exports(as % of merchandise exports) in Cuba in 2006?
Provide a short and direct response. 0.85. What is the difference between the Exports(as % of merchandise exports) in High income: nonOECD in 2005 and the Exports(as % of merchandise exports) in Senegal in 2006?
Your answer should be compact. -4.27. What is the difference between the Exports(as % of merchandise exports) of High income: nonOECD in 2005 and the Exports(as % of merchandise exports) of Sweden in 2006?
Ensure brevity in your answer.  -2.96. What is the difference between the Exports(as % of merchandise exports) of Cuba in 2005 and the Exports(as % of merchandise exports) of Senegal in 2006?
Offer a very short reply. -5.11. What is the difference between the Exports(as % of merchandise exports) of Cuba in 2005 and the Exports(as % of merchandise exports) of Sweden in 2006?
Your answer should be compact. -3.8. What is the difference between the Exports(as % of merchandise exports) in Senegal in 2005 and the Exports(as % of merchandise exports) in Sweden in 2006?
Your response must be concise. -1.84. What is the average Exports(as % of merchandise exports) of High income: nonOECD per year?
Give a very brief answer. 1.08. What is the average Exports(as % of merchandise exports) in Cuba per year?
Give a very brief answer. 0.19. What is the average Exports(as % of merchandise exports) in Senegal per year?
Your answer should be compact. 3.2. What is the average Exports(as % of merchandise exports) in Sweden per year?
Keep it short and to the point. 4.01. In the year 1999, what is the difference between the Exports(as % of merchandise exports) in High income: nonOECD and Exports(as % of merchandise exports) in Cuba?
Your answer should be compact. 0.83. In the year 1999, what is the difference between the Exports(as % of merchandise exports) in High income: nonOECD and Exports(as % of merchandise exports) in Senegal?
Provide a succinct answer. -1.56. In the year 1999, what is the difference between the Exports(as % of merchandise exports) of High income: nonOECD and Exports(as % of merchandise exports) of Sweden?
Offer a terse response. -0.07. In the year 1999, what is the difference between the Exports(as % of merchandise exports) of Cuba and Exports(as % of merchandise exports) of Senegal?
Offer a very short reply. -2.39. In the year 1999, what is the difference between the Exports(as % of merchandise exports) of Cuba and Exports(as % of merchandise exports) of Sweden?
Offer a very short reply. -0.9. In the year 1999, what is the difference between the Exports(as % of merchandise exports) in Senegal and Exports(as % of merchandise exports) in Sweden?
Give a very brief answer. 1.5. In the year 2000, what is the difference between the Exports(as % of merchandise exports) of High income: nonOECD and Exports(as % of merchandise exports) of Cuba?
Ensure brevity in your answer.  0.85. In the year 2000, what is the difference between the Exports(as % of merchandise exports) of High income: nonOECD and Exports(as % of merchandise exports) of Senegal?
Offer a terse response. -0.69. In the year 2000, what is the difference between the Exports(as % of merchandise exports) of High income: nonOECD and Exports(as % of merchandise exports) of Sweden?
Give a very brief answer. -3.67. In the year 2000, what is the difference between the Exports(as % of merchandise exports) in Cuba and Exports(as % of merchandise exports) in Senegal?
Provide a short and direct response. -1.55. In the year 2000, what is the difference between the Exports(as % of merchandise exports) of Cuba and Exports(as % of merchandise exports) of Sweden?
Provide a succinct answer. -4.52. In the year 2000, what is the difference between the Exports(as % of merchandise exports) of Senegal and Exports(as % of merchandise exports) of Sweden?
Make the answer very short. -2.98. In the year 2001, what is the difference between the Exports(as % of merchandise exports) in High income: nonOECD and Exports(as % of merchandise exports) in Cuba?
Ensure brevity in your answer.  0.85. In the year 2001, what is the difference between the Exports(as % of merchandise exports) of High income: nonOECD and Exports(as % of merchandise exports) of Senegal?
Make the answer very short. -1.3. In the year 2001, what is the difference between the Exports(as % of merchandise exports) of High income: nonOECD and Exports(as % of merchandise exports) of Sweden?
Your response must be concise. -3.76. In the year 2001, what is the difference between the Exports(as % of merchandise exports) of Cuba and Exports(as % of merchandise exports) of Senegal?
Provide a short and direct response. -2.15. In the year 2001, what is the difference between the Exports(as % of merchandise exports) in Cuba and Exports(as % of merchandise exports) in Sweden?
Provide a short and direct response. -4.62. In the year 2001, what is the difference between the Exports(as % of merchandise exports) of Senegal and Exports(as % of merchandise exports) of Sweden?
Offer a very short reply. -2.47. In the year 2002, what is the difference between the Exports(as % of merchandise exports) of High income: nonOECD and Exports(as % of merchandise exports) of Cuba?
Offer a very short reply. 0.95. In the year 2002, what is the difference between the Exports(as % of merchandise exports) in High income: nonOECD and Exports(as % of merchandise exports) in Senegal?
Your answer should be very brief. -4.03. In the year 2002, what is the difference between the Exports(as % of merchandise exports) in High income: nonOECD and Exports(as % of merchandise exports) in Sweden?
Your answer should be very brief. -3.59. In the year 2002, what is the difference between the Exports(as % of merchandise exports) in Cuba and Exports(as % of merchandise exports) in Senegal?
Keep it short and to the point. -4.99. In the year 2002, what is the difference between the Exports(as % of merchandise exports) of Cuba and Exports(as % of merchandise exports) of Sweden?
Your answer should be compact. -4.55. In the year 2002, what is the difference between the Exports(as % of merchandise exports) in Senegal and Exports(as % of merchandise exports) in Sweden?
Your response must be concise. 0.44. In the year 2003, what is the difference between the Exports(as % of merchandise exports) in High income: nonOECD and Exports(as % of merchandise exports) in Cuba?
Provide a succinct answer. 0.96. In the year 2003, what is the difference between the Exports(as % of merchandise exports) in High income: nonOECD and Exports(as % of merchandise exports) in Senegal?
Your response must be concise. -2.29. In the year 2003, what is the difference between the Exports(as % of merchandise exports) of High income: nonOECD and Exports(as % of merchandise exports) of Sweden?
Your answer should be very brief. -3.32. In the year 2003, what is the difference between the Exports(as % of merchandise exports) in Cuba and Exports(as % of merchandise exports) in Senegal?
Keep it short and to the point. -3.25. In the year 2003, what is the difference between the Exports(as % of merchandise exports) in Cuba and Exports(as % of merchandise exports) in Sweden?
Your answer should be very brief. -4.28. In the year 2003, what is the difference between the Exports(as % of merchandise exports) in Senegal and Exports(as % of merchandise exports) in Sweden?
Your response must be concise. -1.03. In the year 2004, what is the difference between the Exports(as % of merchandise exports) in High income: nonOECD and Exports(as % of merchandise exports) in Cuba?
Provide a succinct answer. 0.98. In the year 2004, what is the difference between the Exports(as % of merchandise exports) in High income: nonOECD and Exports(as % of merchandise exports) in Senegal?
Provide a succinct answer. -1.68. In the year 2004, what is the difference between the Exports(as % of merchandise exports) of High income: nonOECD and Exports(as % of merchandise exports) of Sweden?
Offer a terse response. -3.08. In the year 2004, what is the difference between the Exports(as % of merchandise exports) of Cuba and Exports(as % of merchandise exports) of Senegal?
Offer a terse response. -2.65. In the year 2004, what is the difference between the Exports(as % of merchandise exports) in Cuba and Exports(as % of merchandise exports) in Sweden?
Provide a succinct answer. -4.06. In the year 2004, what is the difference between the Exports(as % of merchandise exports) in Senegal and Exports(as % of merchandise exports) in Sweden?
Offer a terse response. -1.4. In the year 2005, what is the difference between the Exports(as % of merchandise exports) in High income: nonOECD and Exports(as % of merchandise exports) in Cuba?
Your answer should be very brief. 0.84. In the year 2005, what is the difference between the Exports(as % of merchandise exports) of High income: nonOECD and Exports(as % of merchandise exports) of Senegal?
Provide a succinct answer. -1.12. In the year 2005, what is the difference between the Exports(as % of merchandise exports) in High income: nonOECD and Exports(as % of merchandise exports) in Sweden?
Ensure brevity in your answer.  -3.02. In the year 2005, what is the difference between the Exports(as % of merchandise exports) of Cuba and Exports(as % of merchandise exports) of Senegal?
Provide a succinct answer. -1.96. In the year 2005, what is the difference between the Exports(as % of merchandise exports) in Cuba and Exports(as % of merchandise exports) in Sweden?
Give a very brief answer. -3.85. In the year 2005, what is the difference between the Exports(as % of merchandise exports) of Senegal and Exports(as % of merchandise exports) of Sweden?
Offer a very short reply. -1.89. In the year 2006, what is the difference between the Exports(as % of merchandise exports) of High income: nonOECD and Exports(as % of merchandise exports) of Cuba?
Ensure brevity in your answer.  0.85. In the year 2006, what is the difference between the Exports(as % of merchandise exports) of High income: nonOECD and Exports(as % of merchandise exports) of Senegal?
Offer a terse response. -4.26. In the year 2006, what is the difference between the Exports(as % of merchandise exports) of High income: nonOECD and Exports(as % of merchandise exports) of Sweden?
Provide a short and direct response. -2.96. In the year 2006, what is the difference between the Exports(as % of merchandise exports) in Cuba and Exports(as % of merchandise exports) in Senegal?
Your response must be concise. -5.12. In the year 2006, what is the difference between the Exports(as % of merchandise exports) in Cuba and Exports(as % of merchandise exports) in Sweden?
Give a very brief answer. -3.81. In the year 2006, what is the difference between the Exports(as % of merchandise exports) in Senegal and Exports(as % of merchandise exports) in Sweden?
Your answer should be very brief. 1.31. What is the ratio of the Exports(as % of merchandise exports) of High income: nonOECD in 1999 to that in 2000?
Your answer should be very brief. 1.1. What is the ratio of the Exports(as % of merchandise exports) in Cuba in 1999 to that in 2000?
Offer a very short reply. 1.62. What is the ratio of the Exports(as % of merchandise exports) in Senegal in 1999 to that in 2000?
Your answer should be very brief. 1.56. What is the ratio of the Exports(as % of merchandise exports) in Sweden in 1999 to that in 2000?
Your answer should be very brief. 0.26. What is the ratio of the Exports(as % of merchandise exports) in High income: nonOECD in 1999 to that in 2001?
Ensure brevity in your answer.  1.12. What is the ratio of the Exports(as % of merchandise exports) of Cuba in 1999 to that in 2001?
Give a very brief answer. 1.84. What is the ratio of the Exports(as % of merchandise exports) in Senegal in 1999 to that in 2001?
Provide a short and direct response. 1.17. What is the ratio of the Exports(as % of merchandise exports) in Sweden in 1999 to that in 2001?
Your answer should be very brief. 0.25. What is the ratio of the Exports(as % of merchandise exports) in High income: nonOECD in 1999 to that in 2002?
Your response must be concise. 0.99. What is the ratio of the Exports(as % of merchandise exports) in Cuba in 1999 to that in 2002?
Offer a terse response. 1.53. What is the ratio of the Exports(as % of merchandise exports) in Senegal in 1999 to that in 2002?
Provide a succinct answer. 0.52. What is the ratio of the Exports(as % of merchandise exports) in Sweden in 1999 to that in 2002?
Ensure brevity in your answer.  0.26. What is the ratio of the Exports(as % of merchandise exports) of High income: nonOECD in 1999 to that in 2003?
Provide a succinct answer. 1. What is the ratio of the Exports(as % of merchandise exports) in Cuba in 1999 to that in 2003?
Keep it short and to the point. 1.65. What is the ratio of the Exports(as % of merchandise exports) in Senegal in 1999 to that in 2003?
Your answer should be compact. 0.79. What is the ratio of the Exports(as % of merchandise exports) of Sweden in 1999 to that in 2003?
Provide a short and direct response. 0.27. What is the ratio of the Exports(as % of merchandise exports) of High income: nonOECD in 1999 to that in 2004?
Your answer should be very brief. 1.05. What is the ratio of the Exports(as % of merchandise exports) in Cuba in 1999 to that in 2004?
Offer a very short reply. 2.65. What is the ratio of the Exports(as % of merchandise exports) of Senegal in 1999 to that in 2004?
Offer a very short reply. 0.98. What is the ratio of the Exports(as % of merchandise exports) in Sweden in 1999 to that in 2004?
Provide a succinct answer. 0.29. What is the ratio of the Exports(as % of merchandise exports) in High income: nonOECD in 1999 to that in 2005?
Ensure brevity in your answer.  1.18. What is the ratio of the Exports(as % of merchandise exports) of Cuba in 1999 to that in 2005?
Provide a succinct answer. 2.25. What is the ratio of the Exports(as % of merchandise exports) in Senegal in 1999 to that in 2005?
Offer a very short reply. 1.29. What is the ratio of the Exports(as % of merchandise exports) in Sweden in 1999 to that in 2005?
Provide a short and direct response. 0.31. What is the ratio of the Exports(as % of merchandise exports) of High income: nonOECD in 1999 to that in 2006?
Your answer should be very brief. 1.17. What is the ratio of the Exports(as % of merchandise exports) of Cuba in 1999 to that in 2006?
Offer a terse response. 2.43. What is the ratio of the Exports(as % of merchandise exports) of Senegal in 1999 to that in 2006?
Offer a terse response. 0.52. What is the ratio of the Exports(as % of merchandise exports) of Sweden in 1999 to that in 2006?
Offer a terse response. 0.31. What is the ratio of the Exports(as % of merchandise exports) in High income: nonOECD in 2000 to that in 2001?
Your answer should be compact. 1.02. What is the ratio of the Exports(as % of merchandise exports) of Cuba in 2000 to that in 2001?
Keep it short and to the point. 1.14. What is the ratio of the Exports(as % of merchandise exports) in Senegal in 2000 to that in 2001?
Your answer should be compact. 0.75. What is the ratio of the Exports(as % of merchandise exports) of Sweden in 2000 to that in 2001?
Give a very brief answer. 0.99. What is the ratio of the Exports(as % of merchandise exports) of High income: nonOECD in 2000 to that in 2002?
Your answer should be compact. 0.9. What is the ratio of the Exports(as % of merchandise exports) in Cuba in 2000 to that in 2002?
Your response must be concise. 0.94. What is the ratio of the Exports(as % of merchandise exports) in Senegal in 2000 to that in 2002?
Offer a very short reply. 0.34. What is the ratio of the Exports(as % of merchandise exports) of High income: nonOECD in 2000 to that in 2003?
Provide a succinct answer. 0.91. What is the ratio of the Exports(as % of merchandise exports) of Cuba in 2000 to that in 2003?
Offer a terse response. 1.02. What is the ratio of the Exports(as % of merchandise exports) of Senegal in 2000 to that in 2003?
Make the answer very short. 0.51. What is the ratio of the Exports(as % of merchandise exports) of Sweden in 2000 to that in 2003?
Your answer should be very brief. 1.05. What is the ratio of the Exports(as % of merchandise exports) in High income: nonOECD in 2000 to that in 2004?
Your answer should be very brief. 0.96. What is the ratio of the Exports(as % of merchandise exports) of Cuba in 2000 to that in 2004?
Offer a very short reply. 1.64. What is the ratio of the Exports(as % of merchandise exports) in Senegal in 2000 to that in 2004?
Your response must be concise. 0.63. What is the ratio of the Exports(as % of merchandise exports) in Sweden in 2000 to that in 2004?
Ensure brevity in your answer.  1.13. What is the ratio of the Exports(as % of merchandise exports) in High income: nonOECD in 2000 to that in 2005?
Your answer should be very brief. 1.07. What is the ratio of the Exports(as % of merchandise exports) of Cuba in 2000 to that in 2005?
Your response must be concise. 1.39. What is the ratio of the Exports(as % of merchandise exports) of Senegal in 2000 to that in 2005?
Your answer should be very brief. 0.83. What is the ratio of the Exports(as % of merchandise exports) of Sweden in 2000 to that in 2005?
Offer a very short reply. 1.18. What is the ratio of the Exports(as % of merchandise exports) of High income: nonOECD in 2000 to that in 2006?
Provide a short and direct response. 1.07. What is the ratio of the Exports(as % of merchandise exports) in Cuba in 2000 to that in 2006?
Offer a terse response. 1.5. What is the ratio of the Exports(as % of merchandise exports) in Senegal in 2000 to that in 2006?
Your response must be concise. 0.33. What is the ratio of the Exports(as % of merchandise exports) in Sweden in 2000 to that in 2006?
Offer a terse response. 1.2. What is the ratio of the Exports(as % of merchandise exports) in High income: nonOECD in 2001 to that in 2002?
Provide a short and direct response. 0.88. What is the ratio of the Exports(as % of merchandise exports) in Cuba in 2001 to that in 2002?
Give a very brief answer. 0.83. What is the ratio of the Exports(as % of merchandise exports) in Senegal in 2001 to that in 2002?
Offer a very short reply. 0.45. What is the ratio of the Exports(as % of merchandise exports) in Sweden in 2001 to that in 2002?
Your answer should be compact. 1.01. What is the ratio of the Exports(as % of merchandise exports) of High income: nonOECD in 2001 to that in 2003?
Give a very brief answer. 0.89. What is the ratio of the Exports(as % of merchandise exports) of Cuba in 2001 to that in 2003?
Keep it short and to the point. 0.9. What is the ratio of the Exports(as % of merchandise exports) in Senegal in 2001 to that in 2003?
Offer a terse response. 0.68. What is the ratio of the Exports(as % of merchandise exports) in Sweden in 2001 to that in 2003?
Your answer should be compact. 1.07. What is the ratio of the Exports(as % of merchandise exports) of High income: nonOECD in 2001 to that in 2004?
Make the answer very short. 0.94. What is the ratio of the Exports(as % of merchandise exports) of Cuba in 2001 to that in 2004?
Keep it short and to the point. 1.44. What is the ratio of the Exports(as % of merchandise exports) in Senegal in 2001 to that in 2004?
Your answer should be very brief. 0.84. What is the ratio of the Exports(as % of merchandise exports) of Sweden in 2001 to that in 2004?
Keep it short and to the point. 1.15. What is the ratio of the Exports(as % of merchandise exports) of High income: nonOECD in 2001 to that in 2005?
Make the answer very short. 1.05. What is the ratio of the Exports(as % of merchandise exports) of Cuba in 2001 to that in 2005?
Ensure brevity in your answer.  1.23. What is the ratio of the Exports(as % of merchandise exports) in Senegal in 2001 to that in 2005?
Give a very brief answer. 1.11. What is the ratio of the Exports(as % of merchandise exports) of Sweden in 2001 to that in 2005?
Offer a terse response. 1.2. What is the ratio of the Exports(as % of merchandise exports) in High income: nonOECD in 2001 to that in 2006?
Ensure brevity in your answer.  1.04. What is the ratio of the Exports(as % of merchandise exports) of Cuba in 2001 to that in 2006?
Provide a succinct answer. 1.32. What is the ratio of the Exports(as % of merchandise exports) in Senegal in 2001 to that in 2006?
Provide a short and direct response. 0.44. What is the ratio of the Exports(as % of merchandise exports) in Sweden in 2001 to that in 2006?
Offer a terse response. 1.22. What is the ratio of the Exports(as % of merchandise exports) of High income: nonOECD in 2002 to that in 2003?
Make the answer very short. 1. What is the ratio of the Exports(as % of merchandise exports) of Cuba in 2002 to that in 2003?
Keep it short and to the point. 1.08. What is the ratio of the Exports(as % of merchandise exports) of Senegal in 2002 to that in 2003?
Keep it short and to the point. 1.51. What is the ratio of the Exports(as % of merchandise exports) in Sweden in 2002 to that in 2003?
Provide a succinct answer. 1.06. What is the ratio of the Exports(as % of merchandise exports) of High income: nonOECD in 2002 to that in 2004?
Keep it short and to the point. 1.06. What is the ratio of the Exports(as % of merchandise exports) in Cuba in 2002 to that in 2004?
Make the answer very short. 1.73. What is the ratio of the Exports(as % of merchandise exports) in Senegal in 2002 to that in 2004?
Provide a short and direct response. 1.87. What is the ratio of the Exports(as % of merchandise exports) in Sweden in 2002 to that in 2004?
Provide a succinct answer. 1.14. What is the ratio of the Exports(as % of merchandise exports) in High income: nonOECD in 2002 to that in 2005?
Your answer should be very brief. 1.19. What is the ratio of the Exports(as % of merchandise exports) in Cuba in 2002 to that in 2005?
Provide a succinct answer. 1.48. What is the ratio of the Exports(as % of merchandise exports) in Senegal in 2002 to that in 2005?
Give a very brief answer. 2.47. What is the ratio of the Exports(as % of merchandise exports) of Sweden in 2002 to that in 2005?
Offer a terse response. 1.19. What is the ratio of the Exports(as % of merchandise exports) of High income: nonOECD in 2002 to that in 2006?
Keep it short and to the point. 1.18. What is the ratio of the Exports(as % of merchandise exports) in Cuba in 2002 to that in 2006?
Your answer should be very brief. 1.59. What is the ratio of the Exports(as % of merchandise exports) in Senegal in 2002 to that in 2006?
Provide a succinct answer. 0.99. What is the ratio of the Exports(as % of merchandise exports) in Sweden in 2002 to that in 2006?
Your answer should be compact. 1.21. What is the ratio of the Exports(as % of merchandise exports) in High income: nonOECD in 2003 to that in 2004?
Your response must be concise. 1.05. What is the ratio of the Exports(as % of merchandise exports) of Cuba in 2003 to that in 2004?
Your answer should be compact. 1.6. What is the ratio of the Exports(as % of merchandise exports) in Senegal in 2003 to that in 2004?
Your response must be concise. 1.24. What is the ratio of the Exports(as % of merchandise exports) of Sweden in 2003 to that in 2004?
Provide a succinct answer. 1.07. What is the ratio of the Exports(as % of merchandise exports) in High income: nonOECD in 2003 to that in 2005?
Your response must be concise. 1.18. What is the ratio of the Exports(as % of merchandise exports) in Cuba in 2003 to that in 2005?
Offer a terse response. 1.37. What is the ratio of the Exports(as % of merchandise exports) of Senegal in 2003 to that in 2005?
Your answer should be compact. 1.64. What is the ratio of the Exports(as % of merchandise exports) of Sweden in 2003 to that in 2005?
Offer a very short reply. 1.12. What is the ratio of the Exports(as % of merchandise exports) in High income: nonOECD in 2003 to that in 2006?
Provide a short and direct response. 1.18. What is the ratio of the Exports(as % of merchandise exports) of Cuba in 2003 to that in 2006?
Your response must be concise. 1.47. What is the ratio of the Exports(as % of merchandise exports) in Senegal in 2003 to that in 2006?
Provide a short and direct response. 0.66. What is the ratio of the Exports(as % of merchandise exports) of Sweden in 2003 to that in 2006?
Offer a terse response. 1.14. What is the ratio of the Exports(as % of merchandise exports) of High income: nonOECD in 2004 to that in 2005?
Make the answer very short. 1.12. What is the ratio of the Exports(as % of merchandise exports) of Cuba in 2004 to that in 2005?
Your response must be concise. 0.85. What is the ratio of the Exports(as % of merchandise exports) in Senegal in 2004 to that in 2005?
Offer a very short reply. 1.32. What is the ratio of the Exports(as % of merchandise exports) in Sweden in 2004 to that in 2005?
Your answer should be compact. 1.05. What is the ratio of the Exports(as % of merchandise exports) in High income: nonOECD in 2004 to that in 2006?
Your response must be concise. 1.12. What is the ratio of the Exports(as % of merchandise exports) of Cuba in 2004 to that in 2006?
Your answer should be compact. 0.92. What is the ratio of the Exports(as % of merchandise exports) in Senegal in 2004 to that in 2006?
Make the answer very short. 0.53. What is the ratio of the Exports(as % of merchandise exports) in Sweden in 2004 to that in 2006?
Provide a succinct answer. 1.06. What is the ratio of the Exports(as % of merchandise exports) in High income: nonOECD in 2005 to that in 2006?
Your answer should be compact. 1. What is the ratio of the Exports(as % of merchandise exports) of Cuba in 2005 to that in 2006?
Keep it short and to the point. 1.08. What is the ratio of the Exports(as % of merchandise exports) of Senegal in 2005 to that in 2006?
Ensure brevity in your answer.  0.4. What is the ratio of the Exports(as % of merchandise exports) of Sweden in 2005 to that in 2006?
Provide a succinct answer. 1.01. What is the difference between the highest and the second highest Exports(as % of merchandise exports) in High income: nonOECD?
Offer a terse response. 0.01. What is the difference between the highest and the second highest Exports(as % of merchandise exports) of Cuba?
Ensure brevity in your answer.  0.11. What is the difference between the highest and the second highest Exports(as % of merchandise exports) in Senegal?
Give a very brief answer. 0.05. What is the difference between the highest and the second highest Exports(as % of merchandise exports) in Sweden?
Your response must be concise. 0.04. What is the difference between the highest and the lowest Exports(as % of merchandise exports) of High income: nonOECD?
Ensure brevity in your answer.  0.18. What is the difference between the highest and the lowest Exports(as % of merchandise exports) in Cuba?
Ensure brevity in your answer.  0.2. What is the difference between the highest and the lowest Exports(as % of merchandise exports) in Senegal?
Ensure brevity in your answer.  3.5. What is the difference between the highest and the lowest Exports(as % of merchandise exports) of Sweden?
Provide a short and direct response. 3.57. 